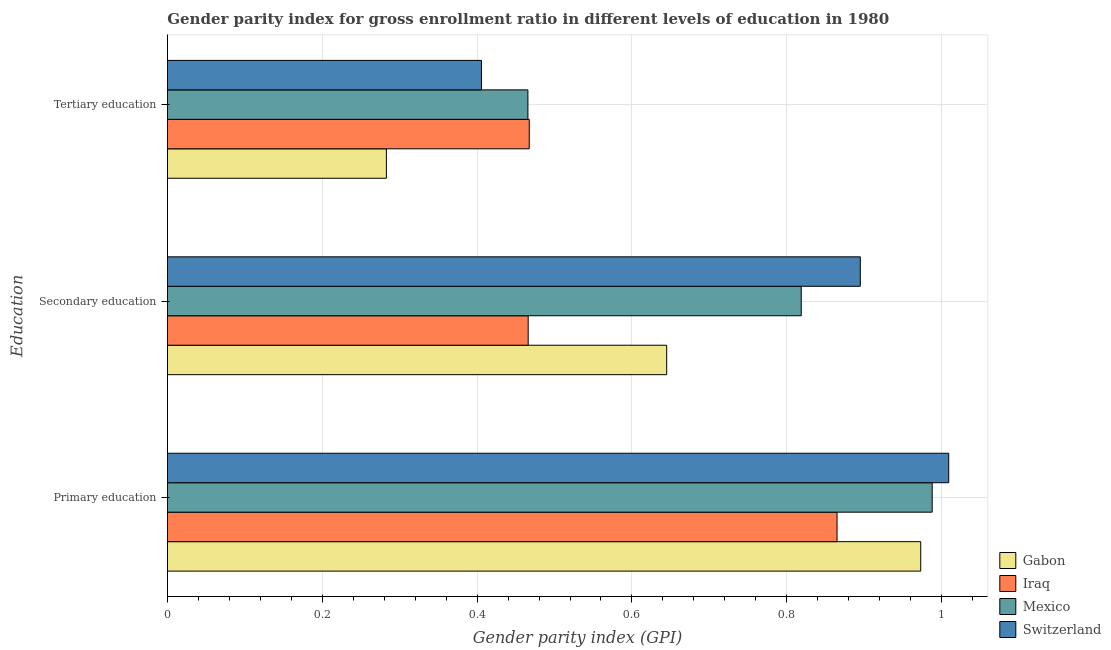How many different coloured bars are there?
Provide a succinct answer. 4. What is the label of the 1st group of bars from the top?
Your answer should be very brief. Tertiary education. What is the gender parity index in secondary education in Switzerland?
Keep it short and to the point. 0.89. Across all countries, what is the maximum gender parity index in tertiary education?
Your response must be concise. 0.47. Across all countries, what is the minimum gender parity index in primary education?
Provide a succinct answer. 0.86. In which country was the gender parity index in primary education maximum?
Offer a terse response. Switzerland. In which country was the gender parity index in secondary education minimum?
Your answer should be very brief. Iraq. What is the total gender parity index in tertiary education in the graph?
Offer a very short reply. 1.62. What is the difference between the gender parity index in primary education in Gabon and that in Iraq?
Give a very brief answer. 0.11. What is the difference between the gender parity index in primary education in Mexico and the gender parity index in secondary education in Iraq?
Give a very brief answer. 0.52. What is the average gender parity index in tertiary education per country?
Provide a succinct answer. 0.41. What is the difference between the gender parity index in primary education and gender parity index in secondary education in Gabon?
Provide a succinct answer. 0.33. In how many countries, is the gender parity index in primary education greater than 0.68 ?
Ensure brevity in your answer.  4. What is the ratio of the gender parity index in secondary education in Gabon to that in Iraq?
Your response must be concise. 1.38. Is the gender parity index in tertiary education in Mexico less than that in Iraq?
Offer a very short reply. Yes. Is the difference between the gender parity index in primary education in Switzerland and Gabon greater than the difference between the gender parity index in secondary education in Switzerland and Gabon?
Make the answer very short. No. What is the difference between the highest and the second highest gender parity index in secondary education?
Give a very brief answer. 0.08. What is the difference between the highest and the lowest gender parity index in secondary education?
Your response must be concise. 0.43. Is the sum of the gender parity index in secondary education in Mexico and Gabon greater than the maximum gender parity index in primary education across all countries?
Ensure brevity in your answer.  Yes. What does the 3rd bar from the bottom in Primary education represents?
Ensure brevity in your answer.  Mexico. How many bars are there?
Ensure brevity in your answer.  12. Are all the bars in the graph horizontal?
Ensure brevity in your answer.  Yes. How many countries are there in the graph?
Make the answer very short. 4. What is the difference between two consecutive major ticks on the X-axis?
Provide a short and direct response. 0.2. Are the values on the major ticks of X-axis written in scientific E-notation?
Give a very brief answer. No. Does the graph contain grids?
Ensure brevity in your answer.  Yes. How are the legend labels stacked?
Offer a terse response. Vertical. What is the title of the graph?
Make the answer very short. Gender parity index for gross enrollment ratio in different levels of education in 1980. What is the label or title of the X-axis?
Your answer should be compact. Gender parity index (GPI). What is the label or title of the Y-axis?
Your answer should be compact. Education. What is the Gender parity index (GPI) in Gabon in Primary education?
Offer a terse response. 0.97. What is the Gender parity index (GPI) in Iraq in Primary education?
Provide a succinct answer. 0.86. What is the Gender parity index (GPI) of Mexico in Primary education?
Ensure brevity in your answer.  0.99. What is the Gender parity index (GPI) in Switzerland in Primary education?
Your answer should be compact. 1.01. What is the Gender parity index (GPI) of Gabon in Secondary education?
Your response must be concise. 0.64. What is the Gender parity index (GPI) in Iraq in Secondary education?
Ensure brevity in your answer.  0.47. What is the Gender parity index (GPI) in Mexico in Secondary education?
Offer a terse response. 0.82. What is the Gender parity index (GPI) in Switzerland in Secondary education?
Keep it short and to the point. 0.89. What is the Gender parity index (GPI) in Gabon in Tertiary education?
Offer a terse response. 0.28. What is the Gender parity index (GPI) of Iraq in Tertiary education?
Your answer should be compact. 0.47. What is the Gender parity index (GPI) of Mexico in Tertiary education?
Ensure brevity in your answer.  0.47. What is the Gender parity index (GPI) of Switzerland in Tertiary education?
Give a very brief answer. 0.41. Across all Education, what is the maximum Gender parity index (GPI) in Gabon?
Give a very brief answer. 0.97. Across all Education, what is the maximum Gender parity index (GPI) in Iraq?
Offer a terse response. 0.86. Across all Education, what is the maximum Gender parity index (GPI) in Mexico?
Ensure brevity in your answer.  0.99. Across all Education, what is the maximum Gender parity index (GPI) in Switzerland?
Your response must be concise. 1.01. Across all Education, what is the minimum Gender parity index (GPI) in Gabon?
Give a very brief answer. 0.28. Across all Education, what is the minimum Gender parity index (GPI) in Iraq?
Provide a short and direct response. 0.47. Across all Education, what is the minimum Gender parity index (GPI) of Mexico?
Ensure brevity in your answer.  0.47. Across all Education, what is the minimum Gender parity index (GPI) of Switzerland?
Your answer should be very brief. 0.41. What is the total Gender parity index (GPI) of Gabon in the graph?
Ensure brevity in your answer.  1.9. What is the total Gender parity index (GPI) of Iraq in the graph?
Ensure brevity in your answer.  1.8. What is the total Gender parity index (GPI) in Mexico in the graph?
Provide a short and direct response. 2.27. What is the total Gender parity index (GPI) in Switzerland in the graph?
Offer a very short reply. 2.31. What is the difference between the Gender parity index (GPI) in Gabon in Primary education and that in Secondary education?
Provide a succinct answer. 0.33. What is the difference between the Gender parity index (GPI) of Iraq in Primary education and that in Secondary education?
Provide a short and direct response. 0.4. What is the difference between the Gender parity index (GPI) in Mexico in Primary education and that in Secondary education?
Provide a succinct answer. 0.17. What is the difference between the Gender parity index (GPI) in Switzerland in Primary education and that in Secondary education?
Your answer should be compact. 0.11. What is the difference between the Gender parity index (GPI) of Gabon in Primary education and that in Tertiary education?
Ensure brevity in your answer.  0.69. What is the difference between the Gender parity index (GPI) of Iraq in Primary education and that in Tertiary education?
Your answer should be very brief. 0.4. What is the difference between the Gender parity index (GPI) in Mexico in Primary education and that in Tertiary education?
Your response must be concise. 0.52. What is the difference between the Gender parity index (GPI) of Switzerland in Primary education and that in Tertiary education?
Give a very brief answer. 0.6. What is the difference between the Gender parity index (GPI) in Gabon in Secondary education and that in Tertiary education?
Your answer should be very brief. 0.36. What is the difference between the Gender parity index (GPI) of Iraq in Secondary education and that in Tertiary education?
Your answer should be very brief. -0. What is the difference between the Gender parity index (GPI) of Mexico in Secondary education and that in Tertiary education?
Make the answer very short. 0.35. What is the difference between the Gender parity index (GPI) in Switzerland in Secondary education and that in Tertiary education?
Offer a terse response. 0.49. What is the difference between the Gender parity index (GPI) of Gabon in Primary education and the Gender parity index (GPI) of Iraq in Secondary education?
Offer a terse response. 0.51. What is the difference between the Gender parity index (GPI) of Gabon in Primary education and the Gender parity index (GPI) of Mexico in Secondary education?
Give a very brief answer. 0.15. What is the difference between the Gender parity index (GPI) in Gabon in Primary education and the Gender parity index (GPI) in Switzerland in Secondary education?
Offer a very short reply. 0.08. What is the difference between the Gender parity index (GPI) of Iraq in Primary education and the Gender parity index (GPI) of Mexico in Secondary education?
Provide a succinct answer. 0.05. What is the difference between the Gender parity index (GPI) of Iraq in Primary education and the Gender parity index (GPI) of Switzerland in Secondary education?
Make the answer very short. -0.03. What is the difference between the Gender parity index (GPI) in Mexico in Primary education and the Gender parity index (GPI) in Switzerland in Secondary education?
Ensure brevity in your answer.  0.09. What is the difference between the Gender parity index (GPI) of Gabon in Primary education and the Gender parity index (GPI) of Iraq in Tertiary education?
Your answer should be very brief. 0.51. What is the difference between the Gender parity index (GPI) of Gabon in Primary education and the Gender parity index (GPI) of Mexico in Tertiary education?
Provide a succinct answer. 0.51. What is the difference between the Gender parity index (GPI) of Gabon in Primary education and the Gender parity index (GPI) of Switzerland in Tertiary education?
Keep it short and to the point. 0.57. What is the difference between the Gender parity index (GPI) of Iraq in Primary education and the Gender parity index (GPI) of Mexico in Tertiary education?
Keep it short and to the point. 0.4. What is the difference between the Gender parity index (GPI) of Iraq in Primary education and the Gender parity index (GPI) of Switzerland in Tertiary education?
Ensure brevity in your answer.  0.46. What is the difference between the Gender parity index (GPI) in Mexico in Primary education and the Gender parity index (GPI) in Switzerland in Tertiary education?
Ensure brevity in your answer.  0.58. What is the difference between the Gender parity index (GPI) in Gabon in Secondary education and the Gender parity index (GPI) in Iraq in Tertiary education?
Make the answer very short. 0.18. What is the difference between the Gender parity index (GPI) in Gabon in Secondary education and the Gender parity index (GPI) in Mexico in Tertiary education?
Provide a succinct answer. 0.18. What is the difference between the Gender parity index (GPI) in Gabon in Secondary education and the Gender parity index (GPI) in Switzerland in Tertiary education?
Your answer should be compact. 0.24. What is the difference between the Gender parity index (GPI) in Iraq in Secondary education and the Gender parity index (GPI) in Mexico in Tertiary education?
Your response must be concise. 0. What is the difference between the Gender parity index (GPI) in Iraq in Secondary education and the Gender parity index (GPI) in Switzerland in Tertiary education?
Ensure brevity in your answer.  0.06. What is the difference between the Gender parity index (GPI) of Mexico in Secondary education and the Gender parity index (GPI) of Switzerland in Tertiary education?
Your response must be concise. 0.41. What is the average Gender parity index (GPI) in Gabon per Education?
Your answer should be compact. 0.63. What is the average Gender parity index (GPI) of Iraq per Education?
Make the answer very short. 0.6. What is the average Gender parity index (GPI) of Mexico per Education?
Offer a very short reply. 0.76. What is the average Gender parity index (GPI) of Switzerland per Education?
Your answer should be compact. 0.77. What is the difference between the Gender parity index (GPI) of Gabon and Gender parity index (GPI) of Iraq in Primary education?
Offer a terse response. 0.11. What is the difference between the Gender parity index (GPI) of Gabon and Gender parity index (GPI) of Mexico in Primary education?
Give a very brief answer. -0.01. What is the difference between the Gender parity index (GPI) of Gabon and Gender parity index (GPI) of Switzerland in Primary education?
Keep it short and to the point. -0.04. What is the difference between the Gender parity index (GPI) in Iraq and Gender parity index (GPI) in Mexico in Primary education?
Offer a very short reply. -0.12. What is the difference between the Gender parity index (GPI) in Iraq and Gender parity index (GPI) in Switzerland in Primary education?
Provide a short and direct response. -0.14. What is the difference between the Gender parity index (GPI) in Mexico and Gender parity index (GPI) in Switzerland in Primary education?
Provide a short and direct response. -0.02. What is the difference between the Gender parity index (GPI) in Gabon and Gender parity index (GPI) in Iraq in Secondary education?
Your answer should be compact. 0.18. What is the difference between the Gender parity index (GPI) in Gabon and Gender parity index (GPI) in Mexico in Secondary education?
Ensure brevity in your answer.  -0.17. What is the difference between the Gender parity index (GPI) of Iraq and Gender parity index (GPI) of Mexico in Secondary education?
Offer a terse response. -0.35. What is the difference between the Gender parity index (GPI) in Iraq and Gender parity index (GPI) in Switzerland in Secondary education?
Offer a very short reply. -0.43. What is the difference between the Gender parity index (GPI) in Mexico and Gender parity index (GPI) in Switzerland in Secondary education?
Provide a succinct answer. -0.08. What is the difference between the Gender parity index (GPI) of Gabon and Gender parity index (GPI) of Iraq in Tertiary education?
Give a very brief answer. -0.18. What is the difference between the Gender parity index (GPI) of Gabon and Gender parity index (GPI) of Mexico in Tertiary education?
Make the answer very short. -0.18. What is the difference between the Gender parity index (GPI) of Gabon and Gender parity index (GPI) of Switzerland in Tertiary education?
Ensure brevity in your answer.  -0.12. What is the difference between the Gender parity index (GPI) of Iraq and Gender parity index (GPI) of Mexico in Tertiary education?
Your answer should be compact. 0. What is the difference between the Gender parity index (GPI) of Iraq and Gender parity index (GPI) of Switzerland in Tertiary education?
Make the answer very short. 0.06. What is the difference between the Gender parity index (GPI) in Mexico and Gender parity index (GPI) in Switzerland in Tertiary education?
Provide a short and direct response. 0.06. What is the ratio of the Gender parity index (GPI) in Gabon in Primary education to that in Secondary education?
Ensure brevity in your answer.  1.51. What is the ratio of the Gender parity index (GPI) of Iraq in Primary education to that in Secondary education?
Your answer should be compact. 1.86. What is the ratio of the Gender parity index (GPI) in Mexico in Primary education to that in Secondary education?
Make the answer very short. 1.21. What is the ratio of the Gender parity index (GPI) of Switzerland in Primary education to that in Secondary education?
Offer a terse response. 1.13. What is the ratio of the Gender parity index (GPI) of Gabon in Primary education to that in Tertiary education?
Offer a very short reply. 3.44. What is the ratio of the Gender parity index (GPI) of Iraq in Primary education to that in Tertiary education?
Offer a very short reply. 1.85. What is the ratio of the Gender parity index (GPI) in Mexico in Primary education to that in Tertiary education?
Ensure brevity in your answer.  2.12. What is the ratio of the Gender parity index (GPI) in Switzerland in Primary education to that in Tertiary education?
Keep it short and to the point. 2.49. What is the ratio of the Gender parity index (GPI) of Gabon in Secondary education to that in Tertiary education?
Keep it short and to the point. 2.28. What is the ratio of the Gender parity index (GPI) in Iraq in Secondary education to that in Tertiary education?
Offer a terse response. 1. What is the ratio of the Gender parity index (GPI) of Mexico in Secondary education to that in Tertiary education?
Offer a terse response. 1.76. What is the ratio of the Gender parity index (GPI) in Switzerland in Secondary education to that in Tertiary education?
Ensure brevity in your answer.  2.21. What is the difference between the highest and the second highest Gender parity index (GPI) of Gabon?
Keep it short and to the point. 0.33. What is the difference between the highest and the second highest Gender parity index (GPI) in Iraq?
Make the answer very short. 0.4. What is the difference between the highest and the second highest Gender parity index (GPI) of Mexico?
Provide a succinct answer. 0.17. What is the difference between the highest and the second highest Gender parity index (GPI) of Switzerland?
Offer a terse response. 0.11. What is the difference between the highest and the lowest Gender parity index (GPI) in Gabon?
Give a very brief answer. 0.69. What is the difference between the highest and the lowest Gender parity index (GPI) in Iraq?
Offer a very short reply. 0.4. What is the difference between the highest and the lowest Gender parity index (GPI) of Mexico?
Provide a succinct answer. 0.52. What is the difference between the highest and the lowest Gender parity index (GPI) in Switzerland?
Your answer should be very brief. 0.6. 